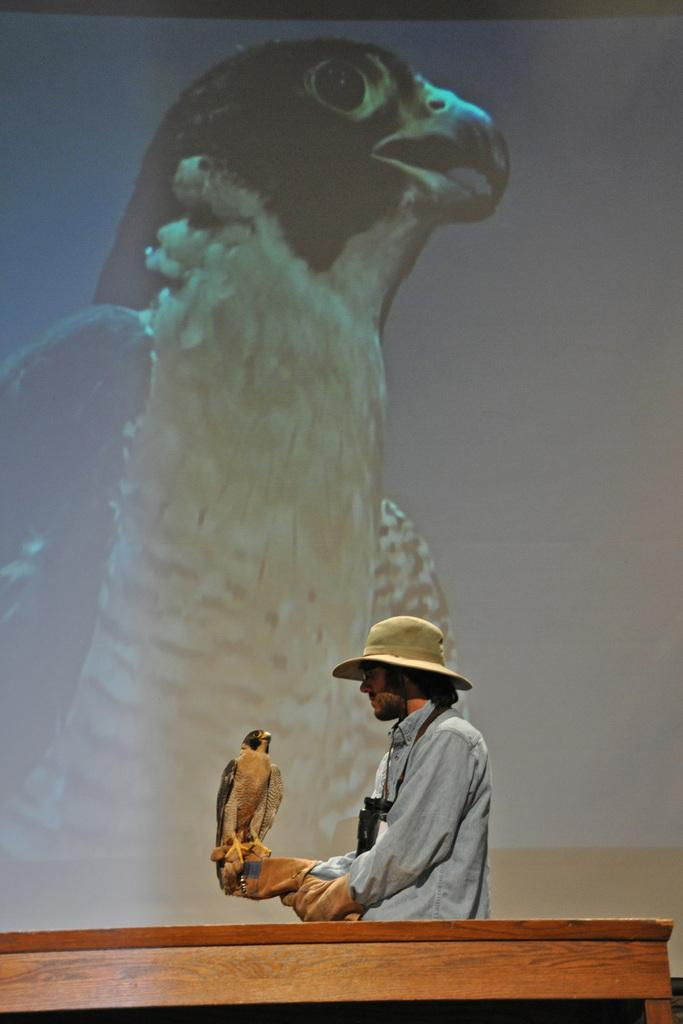Who or what is the main subject in the image? There is a person in the image. What is the person wearing on their head? The person is wearing a hat. What is the person holding in the image? The person is holding an eagle. Can you identify any other objects in the image? Yes, there is a projector in the image. What type of vein is visible in the image? There is no vein visible in the image. What authority does the person in the image hold? The image does not provide any information about the person's authority. 